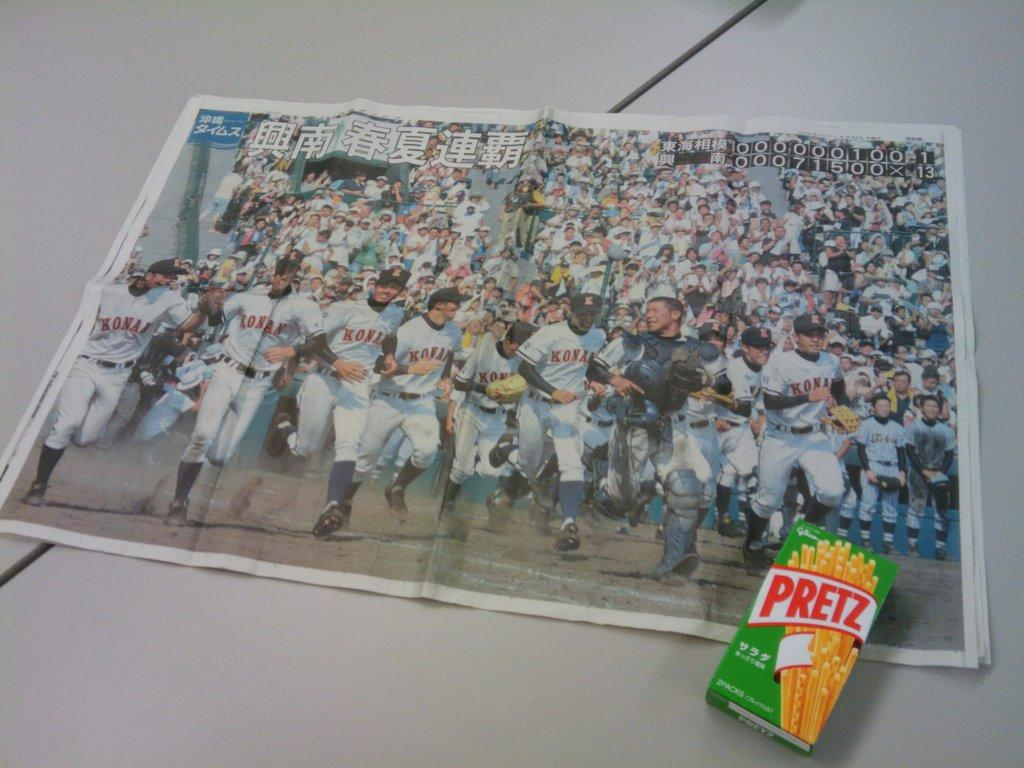What is placed on the table in the image? There is a paper and a carton placed on the table. Can you describe the paper on the table? The paper is placed on the table. What else is placed on the table besides the paper? There is a carton placed on the table. What type of hose is connected to the carton on the table? There is no hose connected to the carton in the image. Is there a ring on the paper on the table? There is no ring mentioned on the paper in the image. 